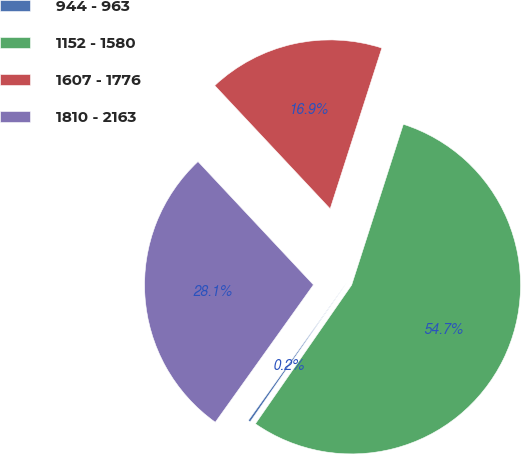<chart> <loc_0><loc_0><loc_500><loc_500><pie_chart><fcel>944 - 963<fcel>1152 - 1580<fcel>1607 - 1776<fcel>1810 - 2163<nl><fcel>0.22%<fcel>54.7%<fcel>16.93%<fcel>28.15%<nl></chart> 